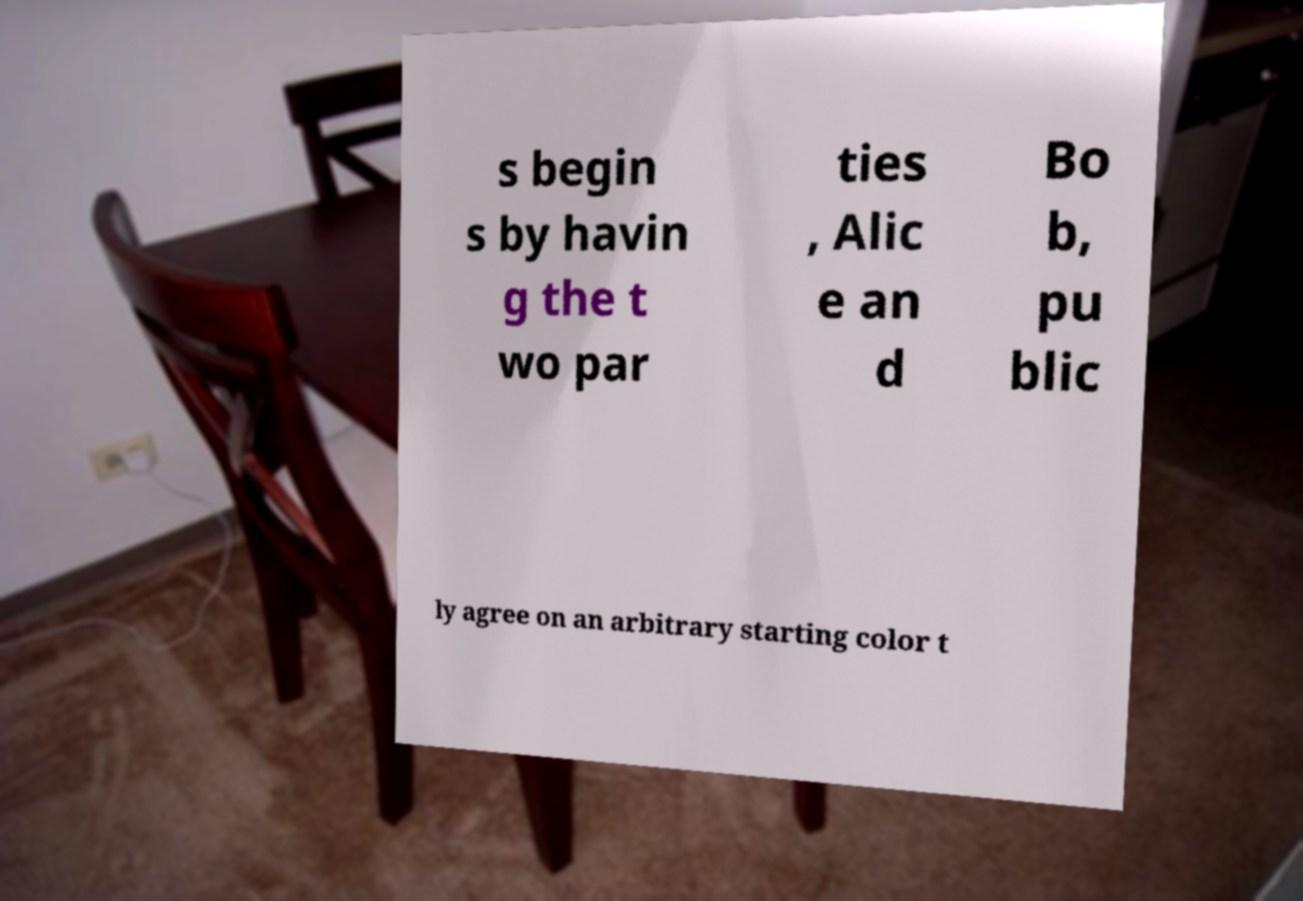Could you extract and type out the text from this image? s begin s by havin g the t wo par ties , Alic e an d Bo b, pu blic ly agree on an arbitrary starting color t 